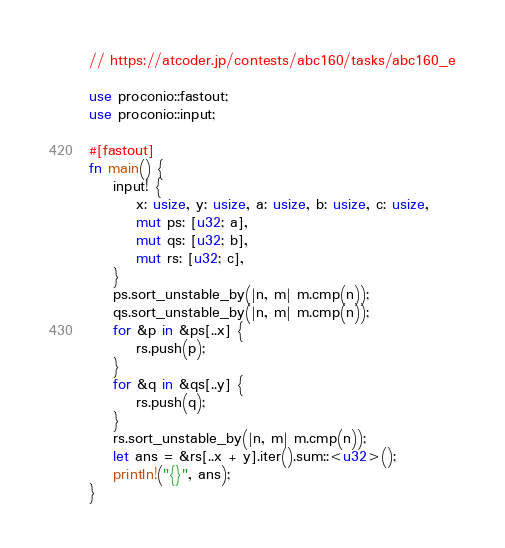Convert code to text. <code><loc_0><loc_0><loc_500><loc_500><_Rust_>// https://atcoder.jp/contests/abc160/tasks/abc160_e

use proconio::fastout;
use proconio::input;

#[fastout]
fn main() {
    input! {
        x: usize, y: usize, a: usize, b: usize, c: usize,
        mut ps: [u32; a],
        mut qs: [u32; b],
        mut rs: [u32; c],
    }
    ps.sort_unstable_by(|n, m| m.cmp(n));
    qs.sort_unstable_by(|n, m| m.cmp(n));
    for &p in &ps[..x] {
        rs.push(p);
    }
    for &q in &qs[..y] {
        rs.push(q);
    }
    rs.sort_unstable_by(|n, m| m.cmp(n));
    let ans = &rs[..x + y].iter().sum::<u32>();
    println!("{}", ans);
}
</code> 